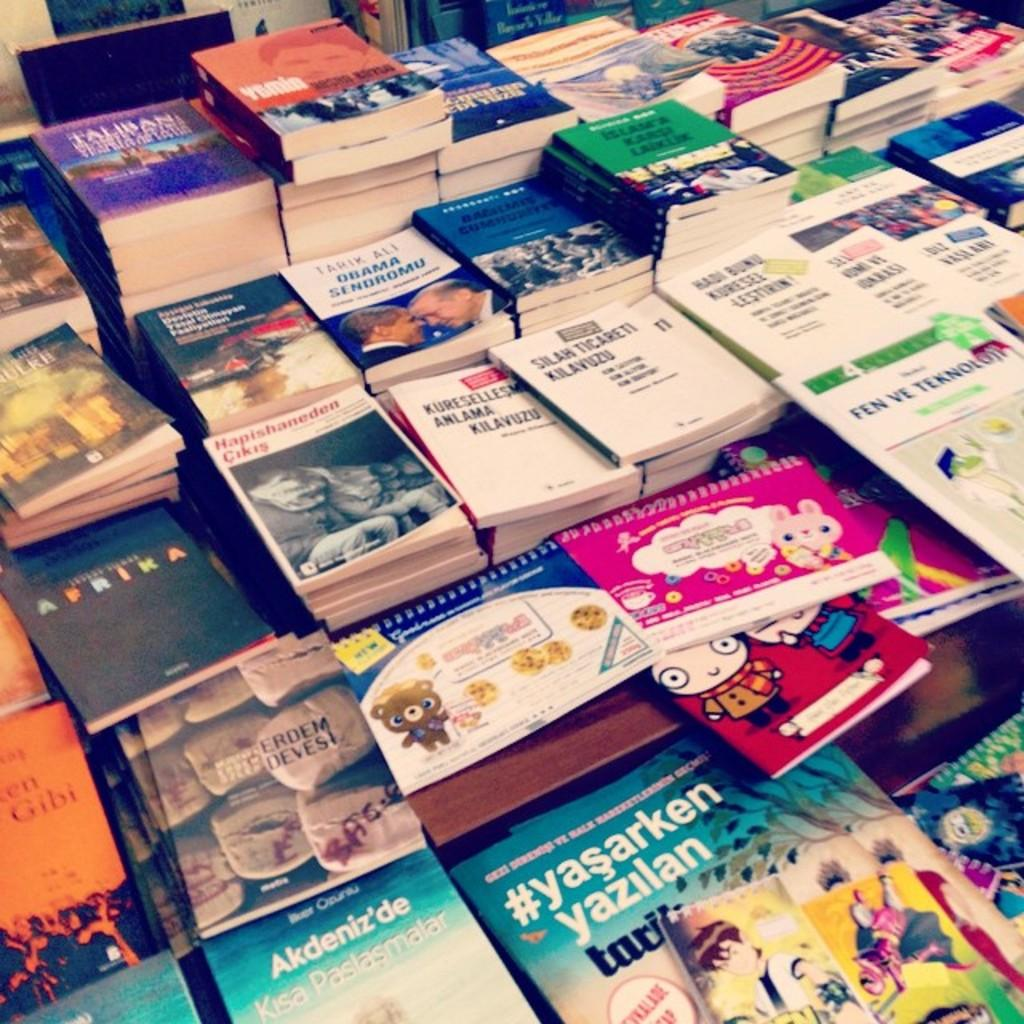<image>
Offer a succinct explanation of the picture presented. Many books, incuding #yasarken yazilan, stacked on a table. 